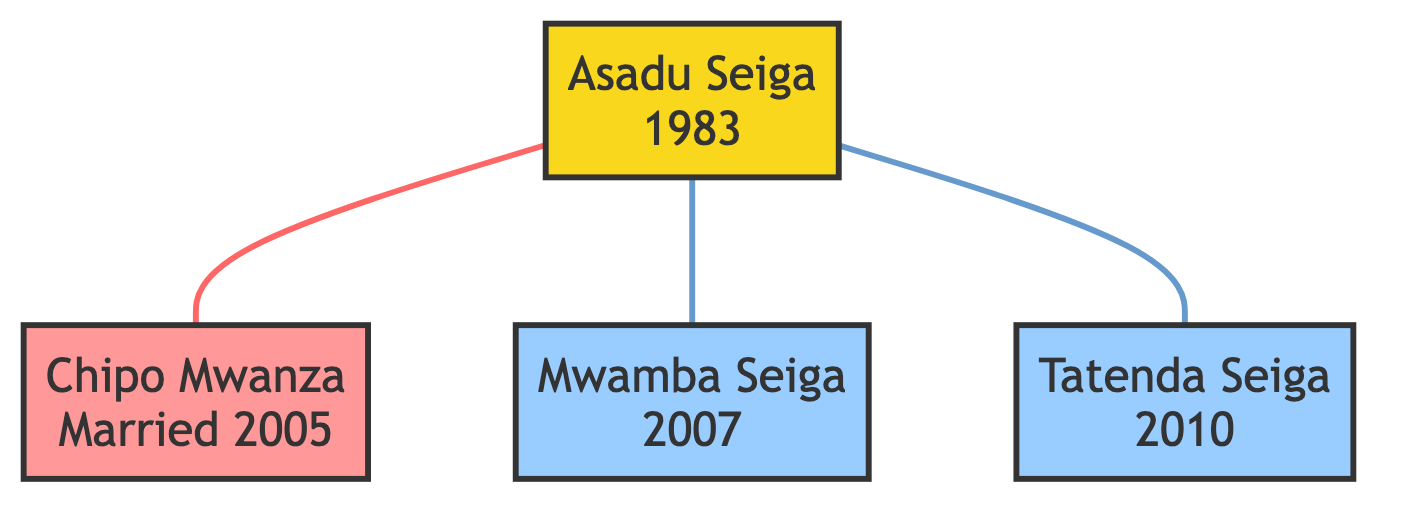What is Asadu Seiga's birth year? The diagram indicates that Asadu Seiga was born in 1983, which is explicitly shown in the node that represents him.
Answer: 1983 Who is Asadu Seiga's spouse? The diagram shows that Asadu Seiga is married to Chipo Mwanza, who is listed directly below Asadu Seiga in the diagram.
Answer: Chipo Mwanza How many children does Asadu Seiga have? By counting the child nodes connected to Asadu Seiga, we see there are two nodes, Mwamba Seiga and Tatenda Seiga, indicating he has two children.
Answer: 2 In what year did Asadu Seiga get married? The diagram states that Asadu Seiga married Chipo Mwanza in 2005, as indicated in the spouse node.
Answer: 2005 Which child was born first? The diagram indicates that Mwamba Seiga was born in 2007, while Tatenda Seiga was born in 2010; thus, Mwamba Seiga is the firstborn.
Answer: Mwamba Seiga What relationship connects Asadu Seiga to Mwamba Seiga? The diagram connects Asadu Seiga directly to Mwamba Seiga through a line, indicating a parent-child relationship, identified as "child."
Answer: Father What is the profession of Asadu Seiga after retirement? The diagram shows that after his retirement in 2018, Asadu Seiga became a cricket commentator and founded a cricket academy, so his professional activities are mentioned in the retirement section.
Answer: Cricket Commentator and Cricket Academy Founder When was Mwamba Seiga born? The diagram specifically shows the birth year of Mwamba Seiga as 2007, clearly indicated next to his name in the diagram.
Answer: 2007 What color represents Chipo Mwanza in the diagram? The diagram assigns a pink color (indicated by the 'spouse' class) to Chipo Mwanza, as she is represented in the spouse node associated with Asadu Seiga.
Answer: Pink 